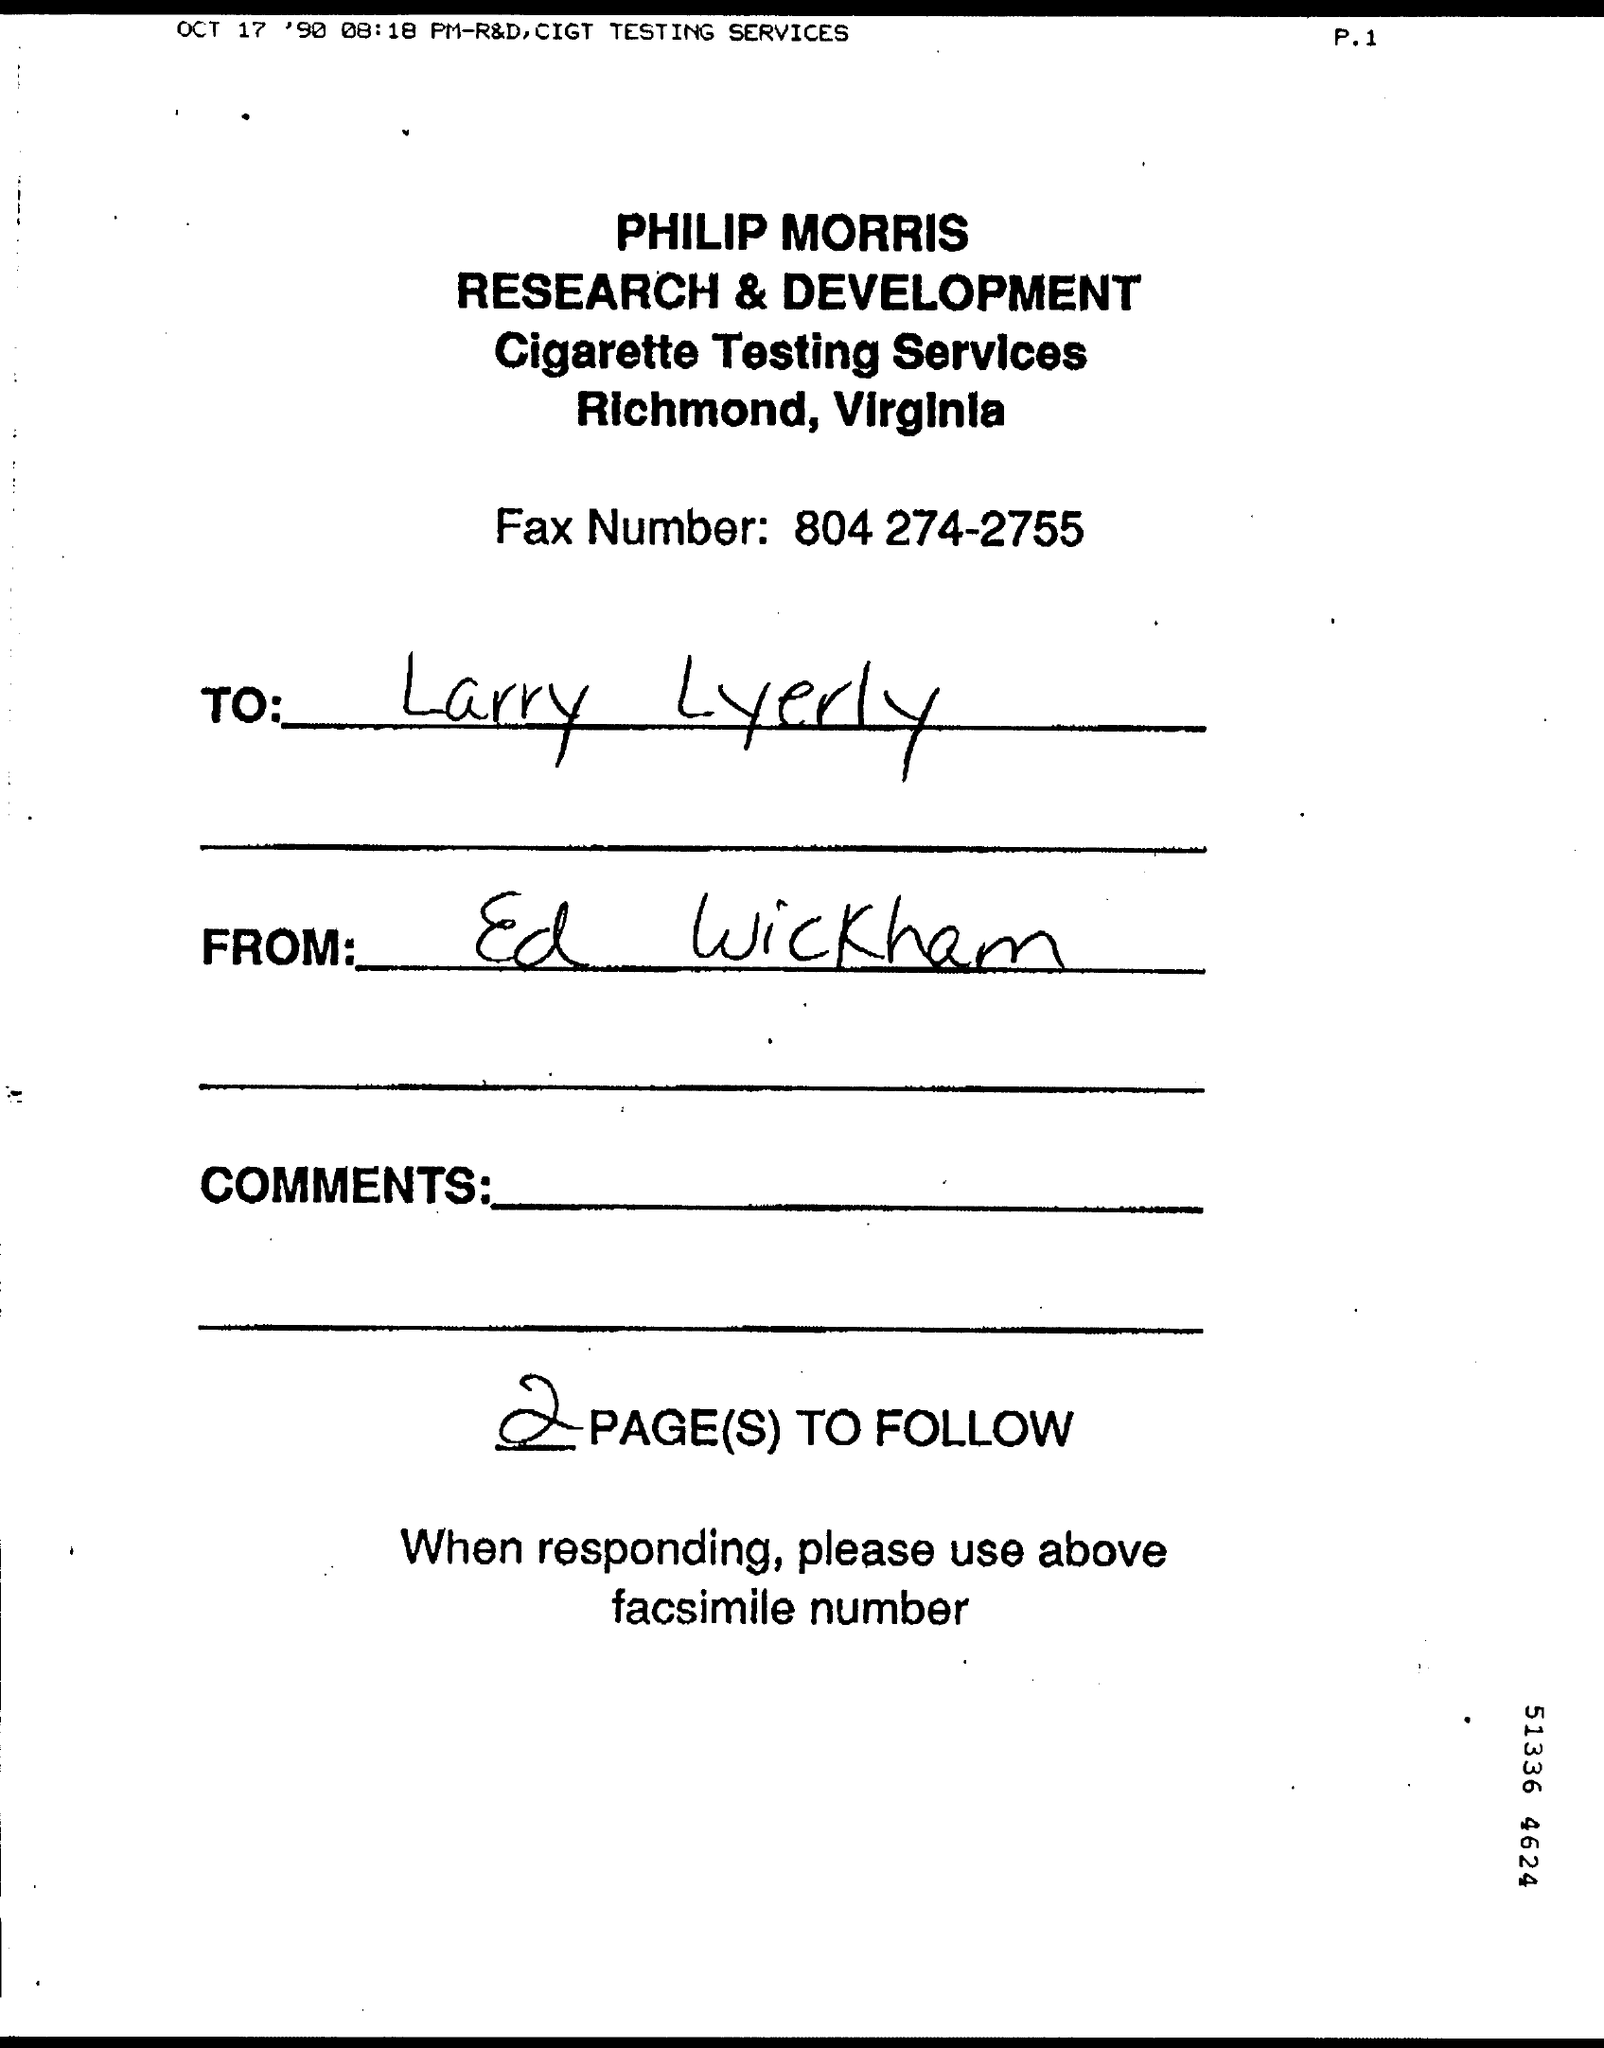Mention a couple of crucial points in this snapshot. I have decided to follow two pages. Cigarette Testing Services are offered. The fax number provided is 804 274-2755. The fax is from Ed Wickham. The fax is addressed to Larry Lyerly. 